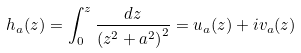Convert formula to latex. <formula><loc_0><loc_0><loc_500><loc_500>h _ { a } ( z ) = \int _ { 0 } ^ { z } \frac { d z } { \left ( z ^ { 2 } + a ^ { 2 } \right ) ^ { 2 } } = u _ { a } ( z ) + i v _ { a } ( z )</formula> 